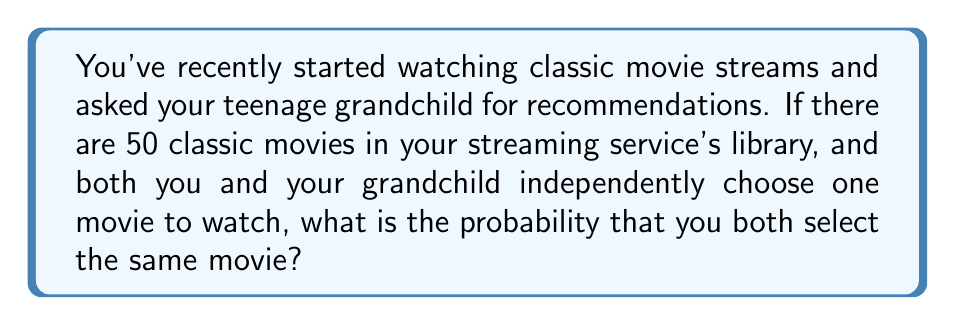Teach me how to tackle this problem. Let's approach this step-by-step:

1) First, we need to understand what the question is asking. We're looking for the probability of two people choosing the same movie out of 50 options.

2) This is a classic probability problem. The probability of an event is the number of favorable outcomes divided by the total number of possible outcomes.

3) In this case:
   - There are 50 possible movies you could choose.
   - Your grandchild also has 50 choices.
   - The total number of possible outcomes (ways you and your grandchild could choose) is $50 \times 50 = 2500$.

4) For a favorable outcome (you both choose the same movie), your grandchild must choose the exact same movie you chose. There are 50 ways this could happen (one for each movie).

5) Therefore, the probability is:

   $$P(\text{same movie}) = \frac{\text{number of favorable outcomes}}{\text{total number of possible outcomes}} = \frac{50}{2500}$$

6) This fraction can be simplified:

   $$\frac{50}{2500} = \frac{1}{50} = 0.02$$

7) We can also express this as a percentage: $0.02 \times 100\% = 2\%$
Answer: $\frac{1}{50}$ or $0.02$ or $2\%$ 